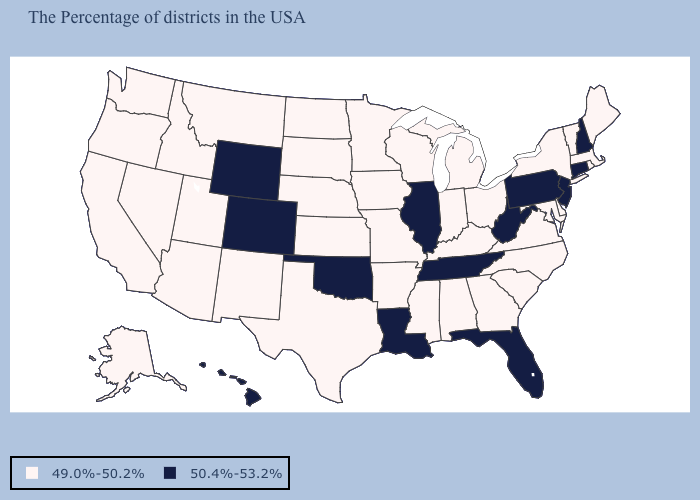Does New Jersey have the lowest value in the USA?
Be succinct. No. Which states hav the highest value in the MidWest?
Answer briefly. Illinois. What is the value of Ohio?
Answer briefly. 49.0%-50.2%. Among the states that border Georgia , which have the highest value?
Short answer required. Florida, Tennessee. Does Vermont have the lowest value in the USA?
Be succinct. Yes. What is the value of North Dakota?
Short answer required. 49.0%-50.2%. What is the value of Montana?
Concise answer only. 49.0%-50.2%. What is the value of Kentucky?
Concise answer only. 49.0%-50.2%. What is the highest value in the USA?
Be succinct. 50.4%-53.2%. Name the states that have a value in the range 49.0%-50.2%?
Quick response, please. Maine, Massachusetts, Rhode Island, Vermont, New York, Delaware, Maryland, Virginia, North Carolina, South Carolina, Ohio, Georgia, Michigan, Kentucky, Indiana, Alabama, Wisconsin, Mississippi, Missouri, Arkansas, Minnesota, Iowa, Kansas, Nebraska, Texas, South Dakota, North Dakota, New Mexico, Utah, Montana, Arizona, Idaho, Nevada, California, Washington, Oregon, Alaska. What is the lowest value in the Northeast?
Answer briefly. 49.0%-50.2%. What is the value of California?
Quick response, please. 49.0%-50.2%. What is the value of Michigan?
Give a very brief answer. 49.0%-50.2%. Among the states that border Maine , which have the highest value?
Answer briefly. New Hampshire. Does Pennsylvania have the highest value in the Northeast?
Quick response, please. Yes. 